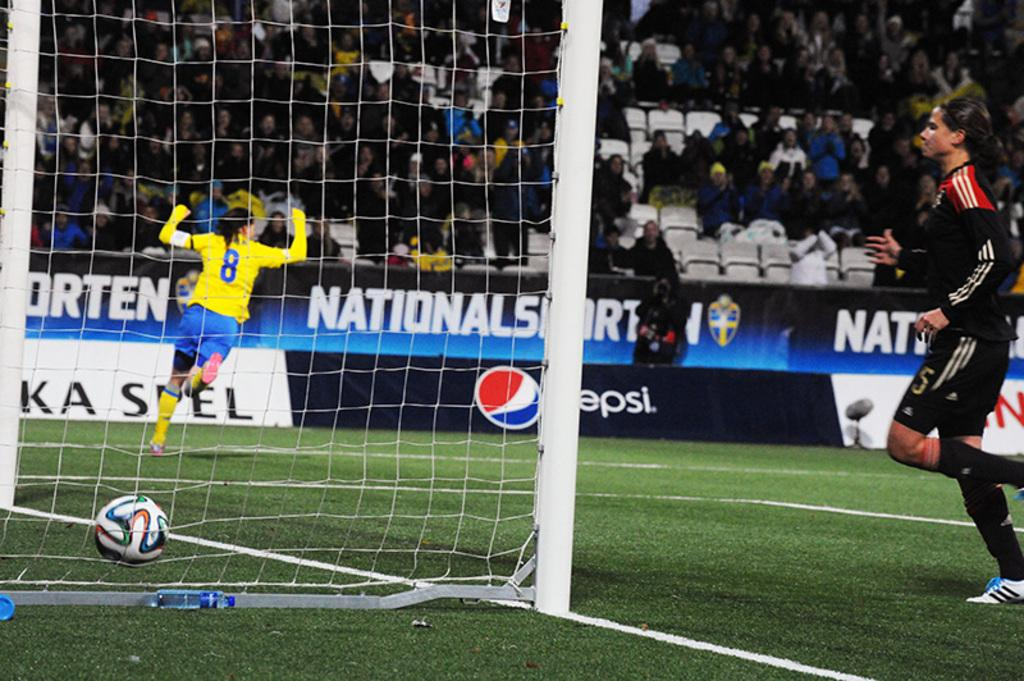What can be seen on the left side of the image? There is a goal post and a ball on the left side of the image. What is the person on the right side of the image doing? The person on the right side of the image is not engaged in any specific activity, but their presence is noted. What is the ground surface made of in the image? The ground has grass in the image. What can be observed in the background of the image? There are many people sitting on chairs in the background of the image. How many candles are on the birthday cake in the image? There is no birthday cake present in the image, so the number of candles cannot be determined. What type of care is being provided to the person on the right side of the image? There is no indication of any care being provided in the image; the person is simply standing on the right side. 